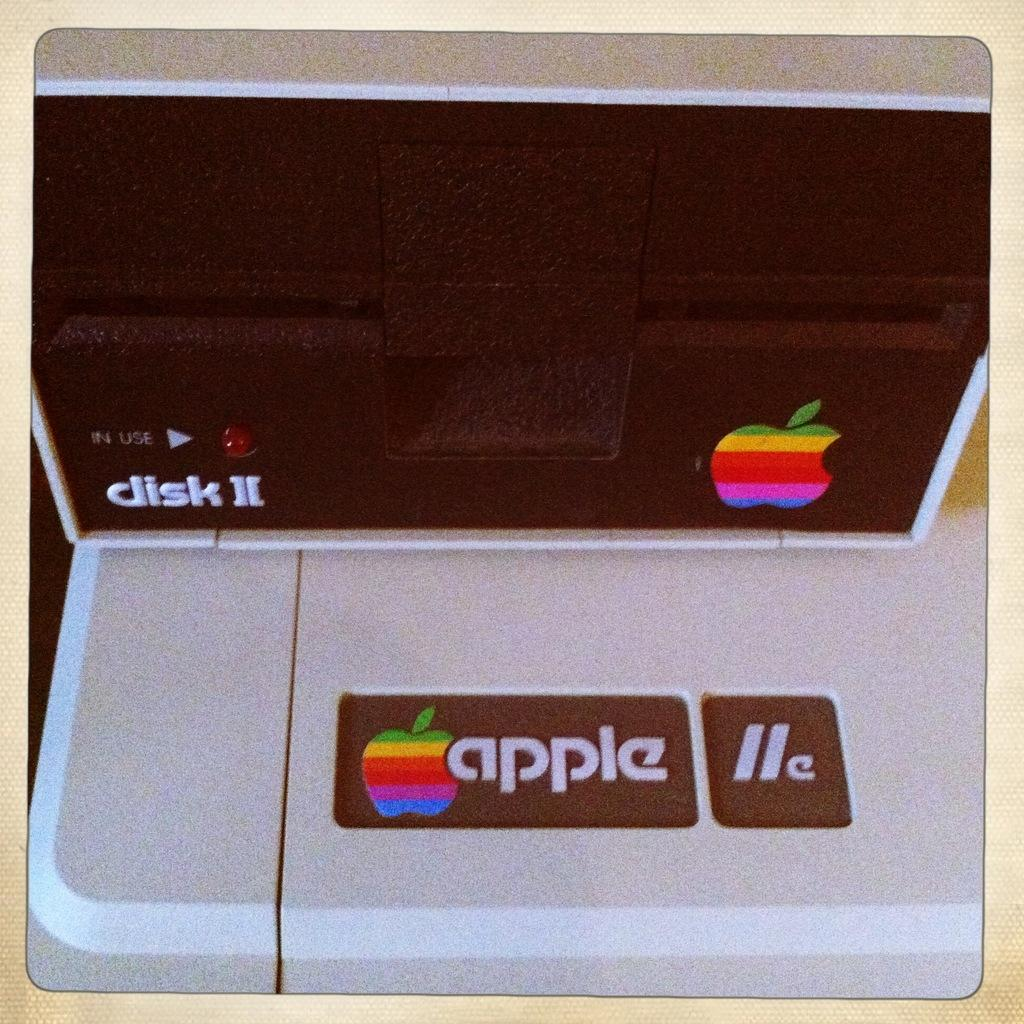<image>
Give a short and clear explanation of the subsequent image. The camera has a apple logo on the front 